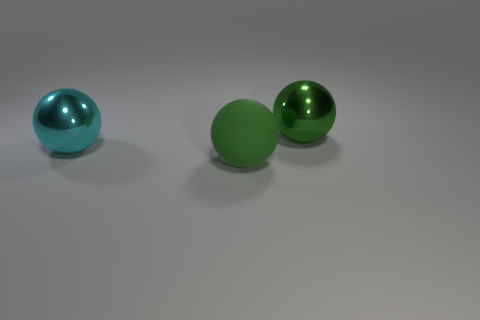Subtract all large metal spheres. How many spheres are left? 1 Add 1 big purple matte spheres. How many objects exist? 4 Add 1 cyan things. How many cyan things are left? 2 Add 2 large matte balls. How many large matte balls exist? 3 Subtract 0 blue cubes. How many objects are left? 3 Subtract all green balls. Subtract all matte spheres. How many objects are left? 0 